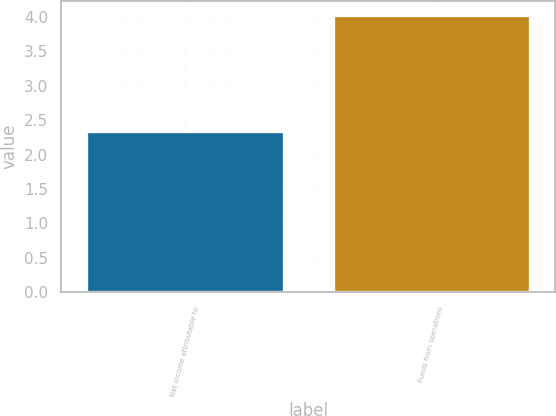Convert chart to OTSL. <chart><loc_0><loc_0><loc_500><loc_500><bar_chart><fcel>Net income attributable to<fcel>Funds from operations<nl><fcel>2.34<fcel>4.03<nl></chart> 